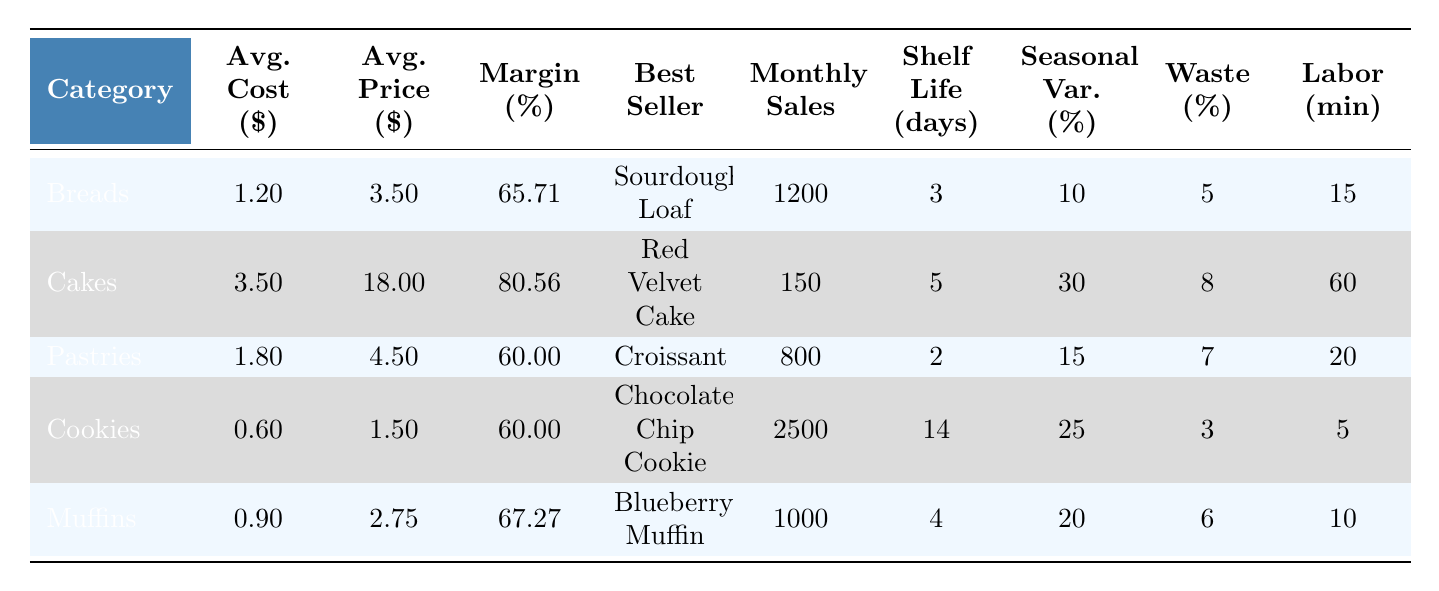What is the average ingredient cost for Cakes? The average ingredient cost for Cakes is listed directly in the table as $3.50.
Answer: $3.50 Which product category has the highest profit margin? The profit margins for the categories are: Breads (65.71%), Cakes (80.56%), Pastries (60.00%), Cookies (60.00%), and Muffins (67.27%). The highest is for Cakes at 80.56%.
Answer: Cakes What is the total monthly sales volume for Cookies and Muffins combined? The monthly sales volume for Cookies is 2500 and for Muffins is 1000. Adding these values gives 2500 + 1000 = 3500.
Answer: 3500 Does the Pastries category have a higher average selling price than the Muffins category? The average selling price for Pastries is $4.50 and for Muffins is $2.75. Since $4.50 is greater than $2.75, the statement is true.
Answer: Yes What is the average shelf life of all the product categories? The shelf lives for Breads, Cakes, Pastries, Cookies, and Muffins are 3, 5, 2, 14, and 4 days respectively. The sum is 3 + 5 + 2 + 14 + 4 = 28 days. Dividing by 5 gives an average of 28/5 = 5.6 days.
Answer: 5.6 days Which product category has the lowest ingredient waste percentage? The ingredient waste percentages are: Breads (5%), Cakes (8%), Pastries (7%), Cookies (3%), and Muffins (6%). The lowest is for Cookies at 3%.
Answer: Cookies Calculate the profit margin for the Breads category in a monetary value per unit. The average selling price for Breads is $3.50 and the average ingredient cost is $1.20. The profit per unit is $3.50 - $1.20 = $2.30, which shows a profit margin of 2.30/3.50 * 100 = 65.71%, verifying the percentage.
Answer: $2.30 How many more monthly sales are there for Cookies compared to Cakes? Monthly sales for Cookies is 2500 and for Cakes is 150. The difference is 2500 - 150 = 2350.
Answer: 2350 Is the seasonal demand variation for Pastries greater than that of Muffins? The seasonal demand variations are 15% for Pastries and 20% for Muffins. Since 15% is less than 20%, the statement is false.
Answer: No What is the combined labor time required to produce one unit of each product category? The labor times for each category are 15, 60, 20, 5, and 10 minutes, respectively. Adding them together gives 15 + 60 + 20 + 5 + 10 = 110 minutes.
Answer: 110 minutes 